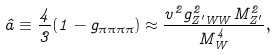<formula> <loc_0><loc_0><loc_500><loc_500>\hat { a } \equiv \frac { 4 } { 3 } ( 1 - g _ { \pi \pi \pi \pi } ) \approx \frac { v ^ { 2 } g _ { Z ^ { \prime } W W } ^ { 2 } M _ { Z ^ { \prime } } ^ { 2 } } { M _ { W } ^ { 4 } } ,</formula> 